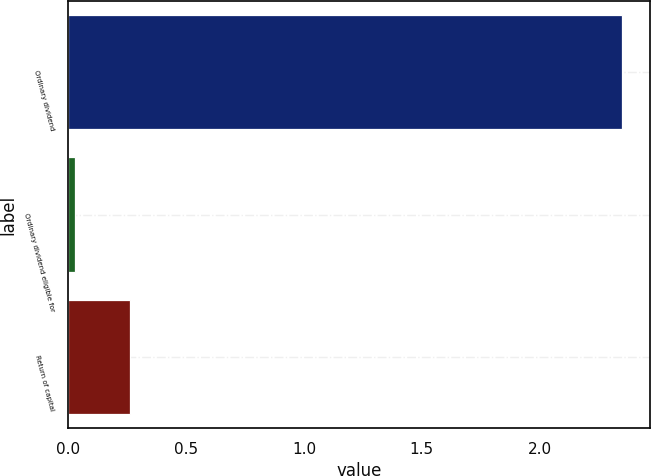<chart> <loc_0><loc_0><loc_500><loc_500><bar_chart><fcel>Ordinary dividend<fcel>Ordinary dividend eligible for<fcel>Return of capital<nl><fcel>2.35<fcel>0.03<fcel>0.26<nl></chart> 